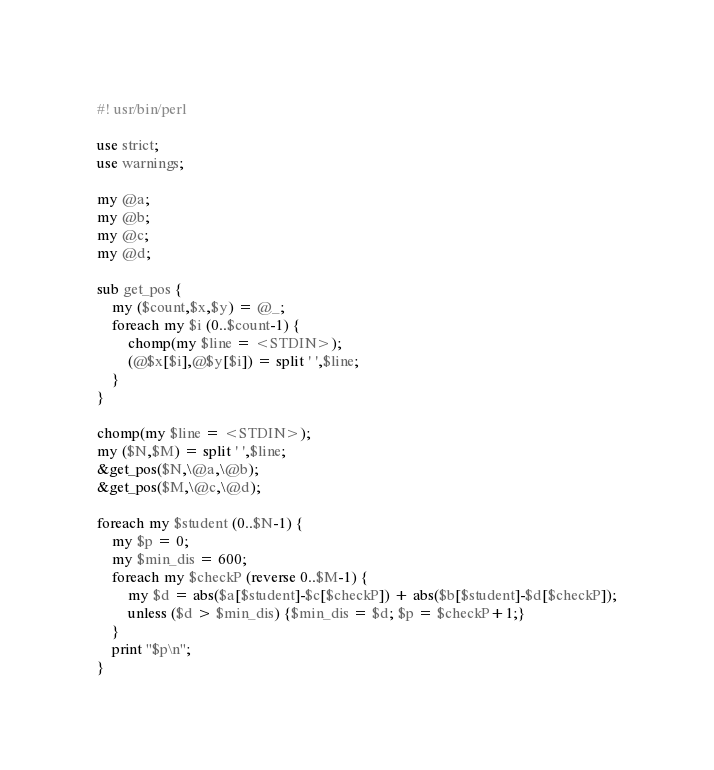<code> <loc_0><loc_0><loc_500><loc_500><_Perl_>#! usr/bin/perl

use strict;
use warnings;

my @a;
my @b;
my @c;
my @d;

sub get_pos {
    my ($count,$x,$y) = @_;
    foreach my $i (0..$count-1) {
        chomp(my $line = <STDIN>);
        (@$x[$i],@$y[$i]) = split ' ',$line;
    }
}

chomp(my $line = <STDIN>);
my ($N,$M) = split ' ',$line;
&get_pos($N,\@a,\@b);
&get_pos($M,\@c,\@d);

foreach my $student (0..$N-1) {
    my $p = 0;
    my $min_dis = 600;
    foreach my $checkP (reverse 0..$M-1) {
        my $d = abs($a[$student]-$c[$checkP]) + abs($b[$student]-$d[$checkP]);
        unless ($d > $min_dis) {$min_dis = $d; $p = $checkP+1;}
    }
    print "$p\n";
}
</code> 